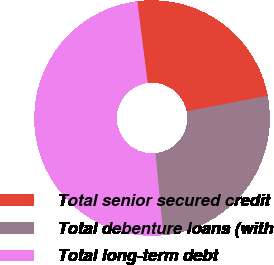Convert chart to OTSL. <chart><loc_0><loc_0><loc_500><loc_500><pie_chart><fcel>Total senior secured credit<fcel>Total debenture loans (with<fcel>Total long-term debt<nl><fcel>23.97%<fcel>26.52%<fcel>49.5%<nl></chart> 